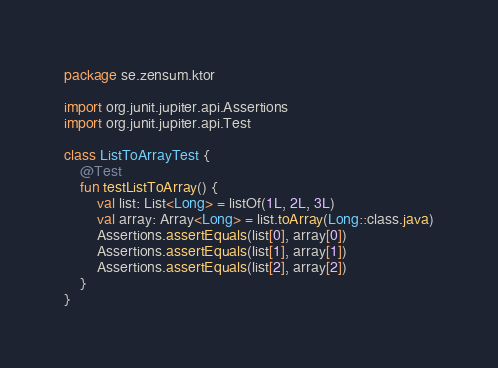<code> <loc_0><loc_0><loc_500><loc_500><_Kotlin_>package se.zensum.ktor

import org.junit.jupiter.api.Assertions
import org.junit.jupiter.api.Test

class ListToArrayTest {
    @Test
    fun testListToArray() {
        val list: List<Long> = listOf(1L, 2L, 3L)
        val array: Array<Long> = list.toArray(Long::class.java)
        Assertions.assertEquals(list[0], array[0])
        Assertions.assertEquals(list[1], array[1])
        Assertions.assertEquals(list[2], array[2])
    }
}</code> 